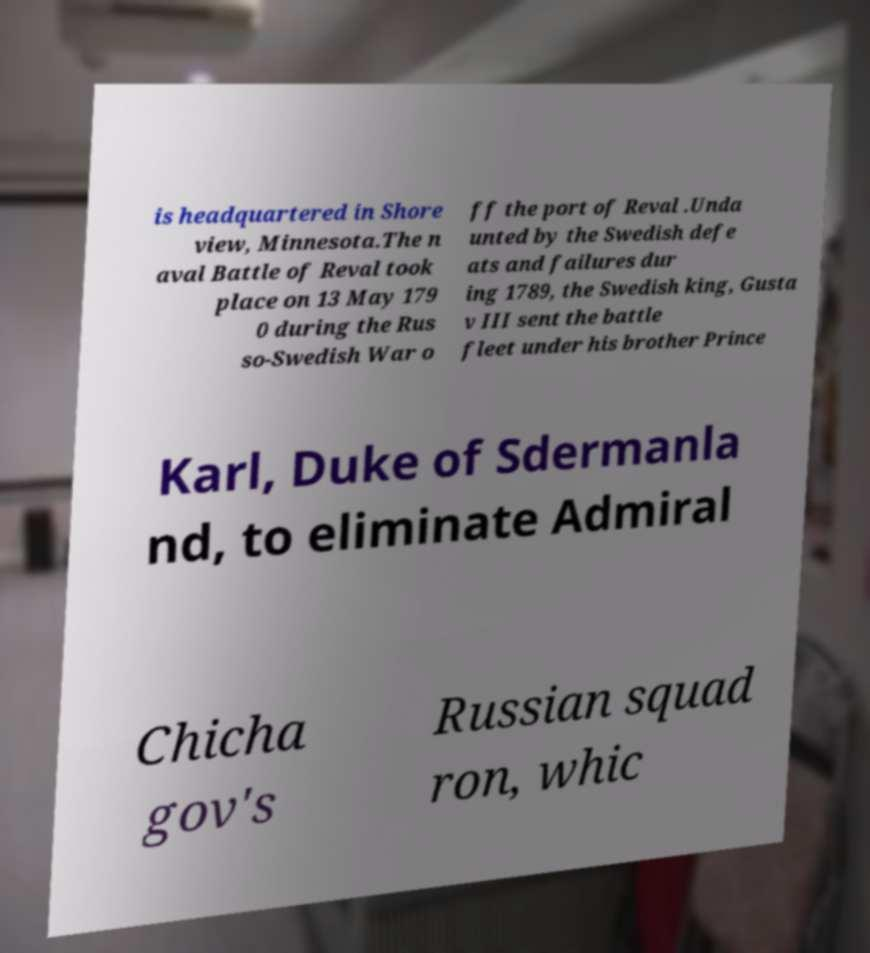There's text embedded in this image that I need extracted. Can you transcribe it verbatim? is headquartered in Shore view, Minnesota.The n aval Battle of Reval took place on 13 May 179 0 during the Rus so-Swedish War o ff the port of Reval .Unda unted by the Swedish defe ats and failures dur ing 1789, the Swedish king, Gusta v III sent the battle fleet under his brother Prince Karl, Duke of Sdermanla nd, to eliminate Admiral Chicha gov's Russian squad ron, whic 